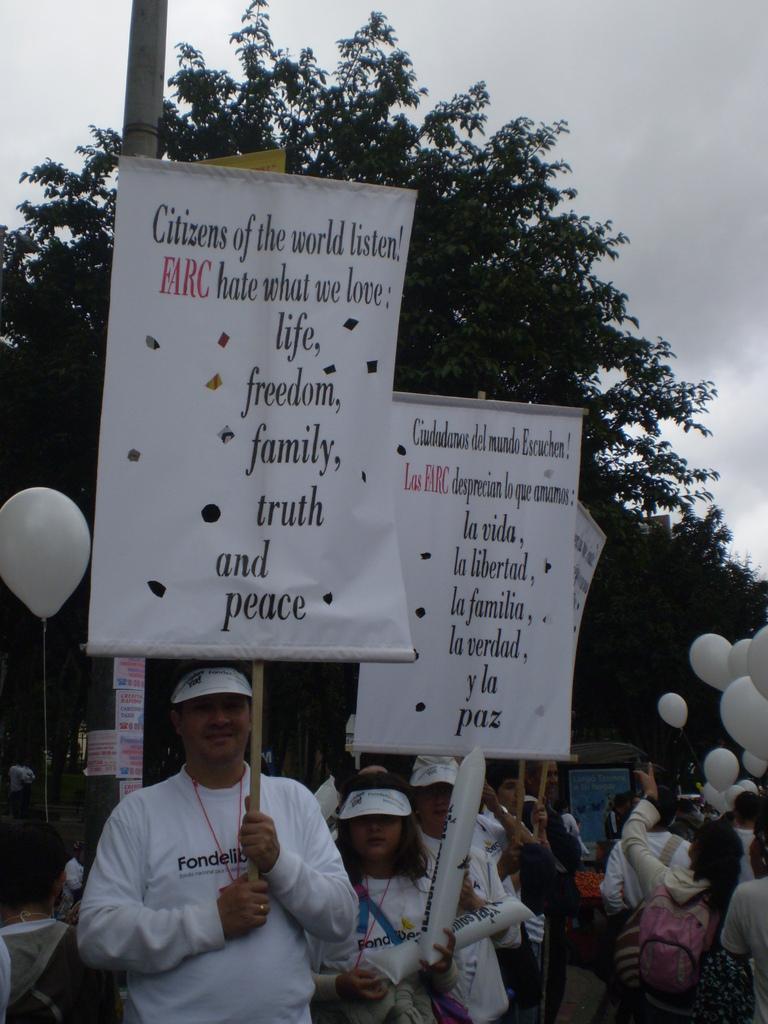Please provide a concise description of this image. In this image I can see few people with different color dresses. I can see few people holding the banners and few people holding the white color balloons. In the background I can see the pole, many trees and the sky. 